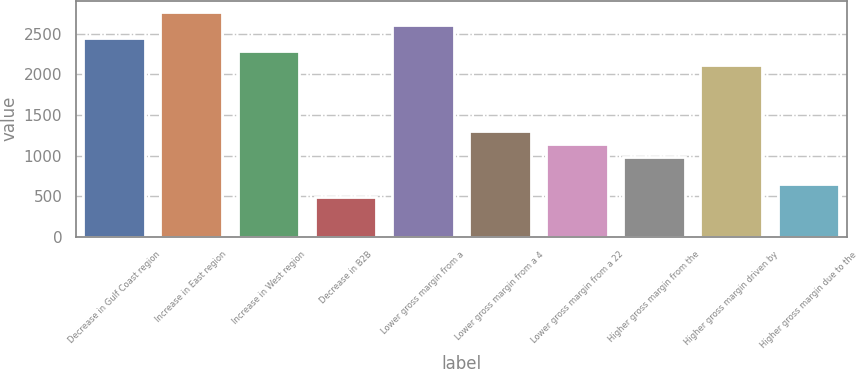Convert chart. <chart><loc_0><loc_0><loc_500><loc_500><bar_chart><fcel>Decrease in Gulf Coast region<fcel>Increase in East region<fcel>Increase in West region<fcel>Decrease in B2B<fcel>Lower gross margin from a<fcel>Lower gross margin from a 4<fcel>Lower gross margin from a 22<fcel>Higher gross margin from the<fcel>Higher gross margin driven by<fcel>Higher gross margin due to the<nl><fcel>2446.5<fcel>2772.3<fcel>2283.6<fcel>491.7<fcel>2609.4<fcel>1306.2<fcel>1143.3<fcel>980.4<fcel>2120.7<fcel>654.6<nl></chart> 